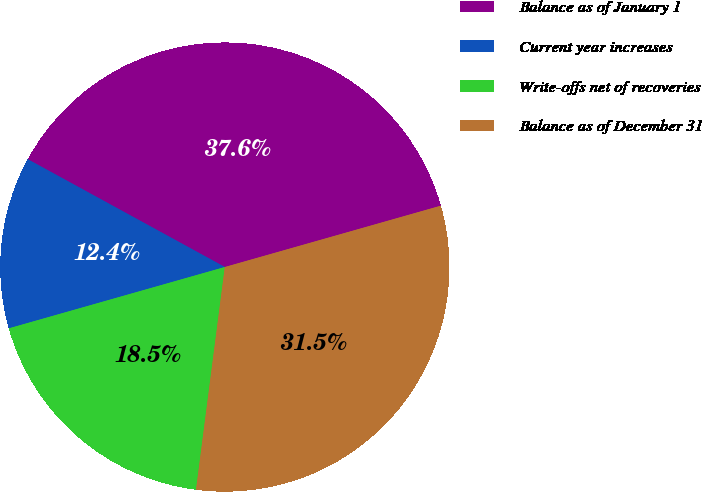<chart> <loc_0><loc_0><loc_500><loc_500><pie_chart><fcel>Balance as of January 1<fcel>Current year increases<fcel>Write-offs net of recoveries<fcel>Balance as of December 31<nl><fcel>37.63%<fcel>12.37%<fcel>18.55%<fcel>31.45%<nl></chart> 